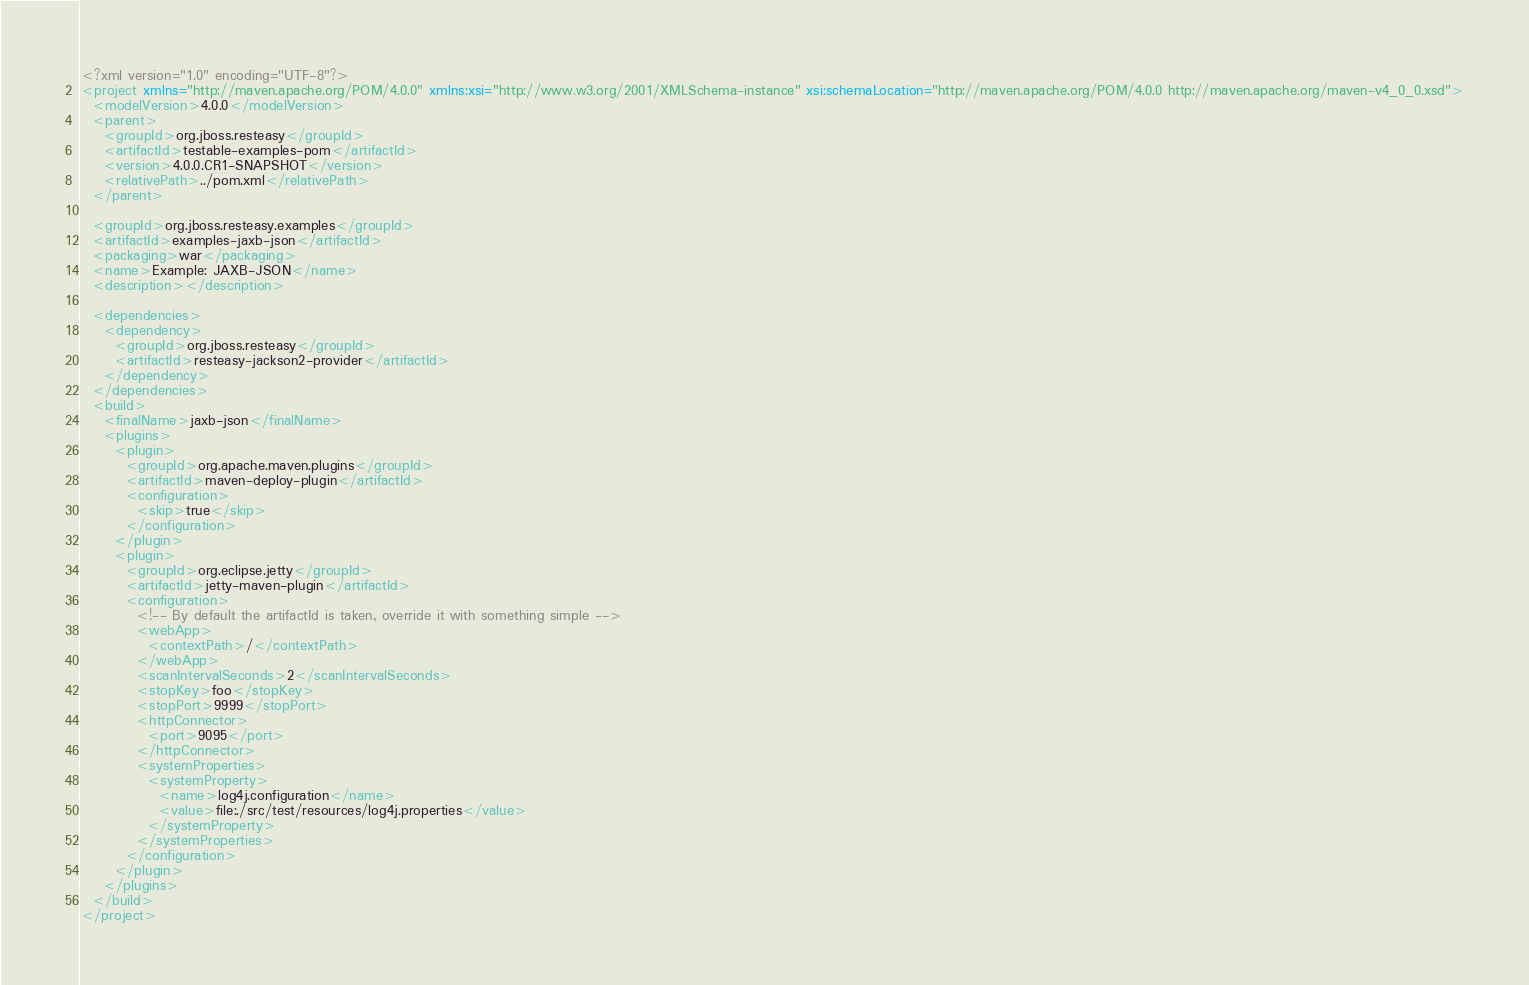<code> <loc_0><loc_0><loc_500><loc_500><_XML_><?xml version="1.0" encoding="UTF-8"?>
<project xmlns="http://maven.apache.org/POM/4.0.0" xmlns:xsi="http://www.w3.org/2001/XMLSchema-instance" xsi:schemaLocation="http://maven.apache.org/POM/4.0.0 http://maven.apache.org/maven-v4_0_0.xsd">
  <modelVersion>4.0.0</modelVersion>
  <parent>
    <groupId>org.jboss.resteasy</groupId>
    <artifactId>testable-examples-pom</artifactId>
    <version>4.0.0.CR1-SNAPSHOT</version>
    <relativePath>../pom.xml</relativePath>
  </parent>

  <groupId>org.jboss.resteasy.examples</groupId>
  <artifactId>examples-jaxb-json</artifactId>
  <packaging>war</packaging>
  <name>Example: JAXB-JSON</name>
  <description></description>

  <dependencies>
    <dependency>
      <groupId>org.jboss.resteasy</groupId>
      <artifactId>resteasy-jackson2-provider</artifactId>
    </dependency>
  </dependencies>
  <build>
    <finalName>jaxb-json</finalName>
    <plugins>
      <plugin>
        <groupId>org.apache.maven.plugins</groupId>
        <artifactId>maven-deploy-plugin</artifactId>
        <configuration>
          <skip>true</skip>
        </configuration>
      </plugin>
      <plugin>
        <groupId>org.eclipse.jetty</groupId>
        <artifactId>jetty-maven-plugin</artifactId>
        <configuration>
          <!-- By default the artifactId is taken, override it with something simple -->
          <webApp>
            <contextPath>/</contextPath>
          </webApp>
          <scanIntervalSeconds>2</scanIntervalSeconds>
          <stopKey>foo</stopKey>
          <stopPort>9999</stopPort>
          <httpConnector>
            <port>9095</port>
          </httpConnector>
          <systemProperties>
            <systemProperty>
              <name>log4j.configuration</name>
              <value>file:./src/test/resources/log4j.properties</value>
            </systemProperty>
          </systemProperties>
        </configuration>
      </plugin>
    </plugins>
  </build>
</project>
</code> 